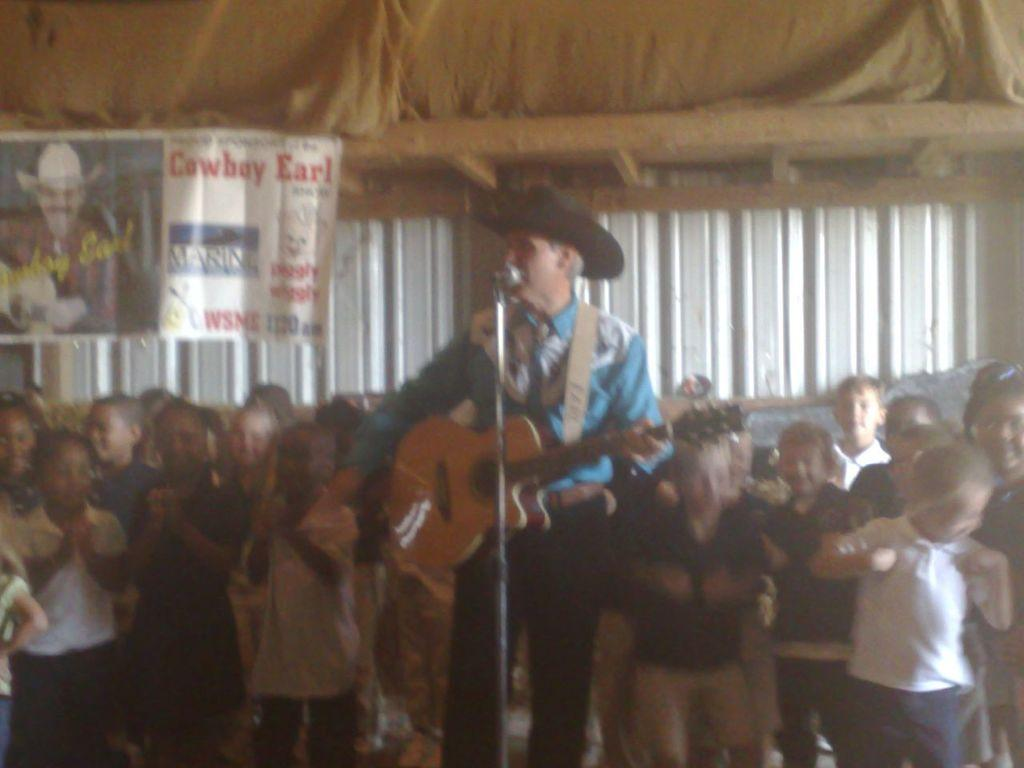What is the man in the image holding? The man is holding a guitar. What is the man doing in the image? The man is standing in front of a microphone. What can be seen in the background of the image? There are children and a wall in the background of the image. What is on the wall in the background? There is a poster on the wall. What type of beef is being served to the giraffe in the image? There is no giraffe or beef present in the image. How does the man feel about his crush in the image? There is no information about a crush in the image, as it focuses on the man holding a guitar and standing in front of a microphone. 